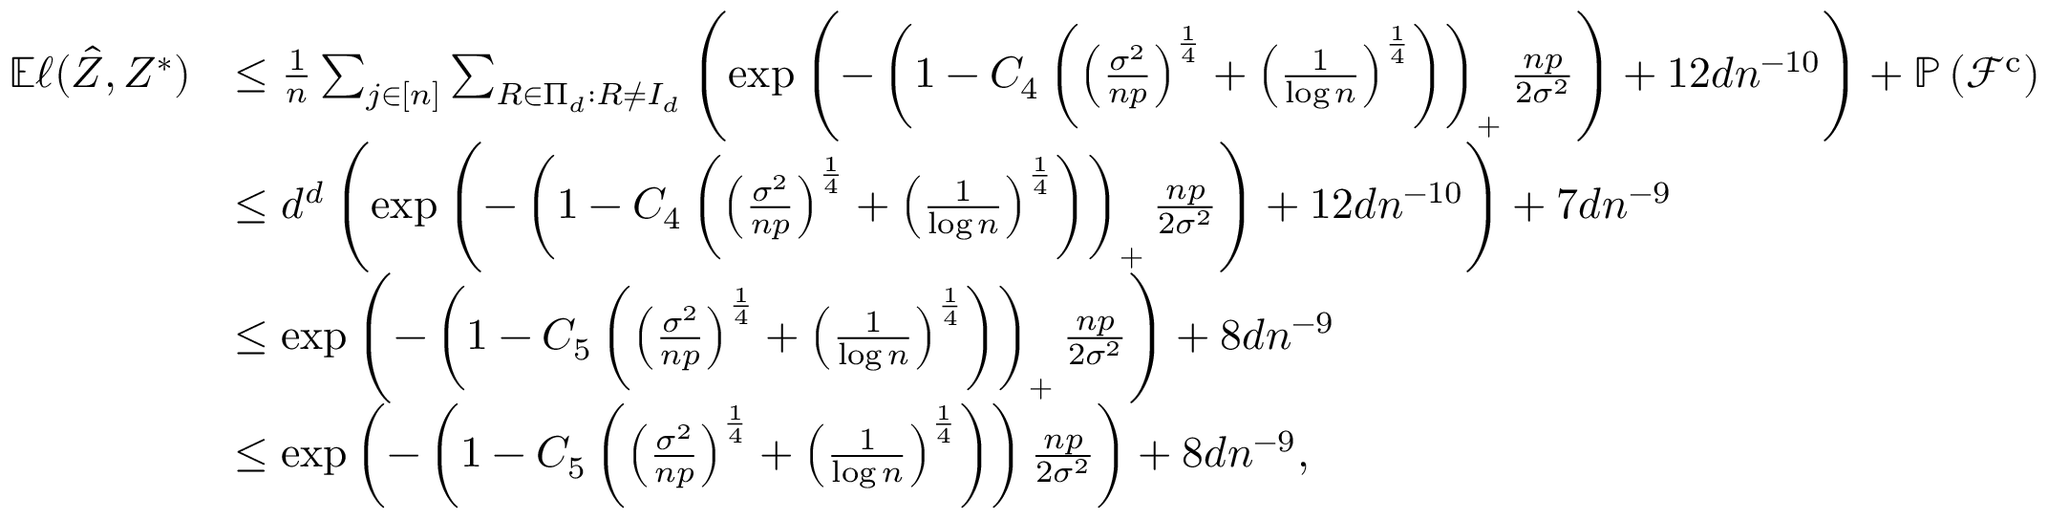<formula> <loc_0><loc_0><loc_500><loc_500>\begin{array} { r l } { \mathbb { E } \ell ( \hat { Z } , Z ^ { * } ) } & { \leq \frac { 1 } { n } \sum _ { j \in [ n ] } \sum _ { R \in \Pi _ { d } \colon R \neq I _ { d } } \left ( \exp \left ( - \left ( 1 - C _ { 4 } \left ( \left ( \frac { \sigma ^ { 2 } } { n p } \right ) ^ { \frac { 1 } { 4 } } + \left ( \frac { 1 } { \log n } \right ) ^ { \frac { 1 } { 4 } } \right ) \right ) _ { + } \frac { n p } { 2 \sigma ^ { 2 } } \right ) + 1 2 d n ^ { - 1 0 } \right ) + \mathbb { P } \left ( \mathcal { F } ^ { c } \right ) } \\ & { \leq d ^ { d } \left ( \exp \left ( - \left ( 1 - C _ { 4 } \left ( \left ( \frac { \sigma ^ { 2 } } { n p } \right ) ^ { \frac { 1 } { 4 } } + \left ( \frac { 1 } { \log n } \right ) ^ { \frac { 1 } { 4 } } \right ) \right ) _ { + } \frac { n p } { 2 \sigma ^ { 2 } } \right ) + 1 2 d n ^ { - 1 0 } \right ) + 7 d n ^ { - 9 } } \\ & { \leq \exp \left ( - \left ( 1 - C _ { 5 } \left ( \left ( \frac { \sigma ^ { 2 } } { n p } \right ) ^ { \frac { 1 } { 4 } } + \left ( \frac { 1 } { \log n } \right ) ^ { \frac { 1 } { 4 } } \right ) \right ) _ { + } \frac { n p } { 2 \sigma ^ { 2 } } \right ) + 8 d n ^ { - 9 } } \\ & { \leq \exp \left ( - \left ( 1 - C _ { 5 } \left ( \left ( \frac { \sigma ^ { 2 } } { n p } \right ) ^ { \frac { 1 } { 4 } } + \left ( \frac { 1 } { \log n } \right ) ^ { \frac { 1 } { 4 } } \right ) \right ) \frac { n p } { 2 \sigma ^ { 2 } } \right ) + 8 d n ^ { - 9 } , } \end{array}</formula> 